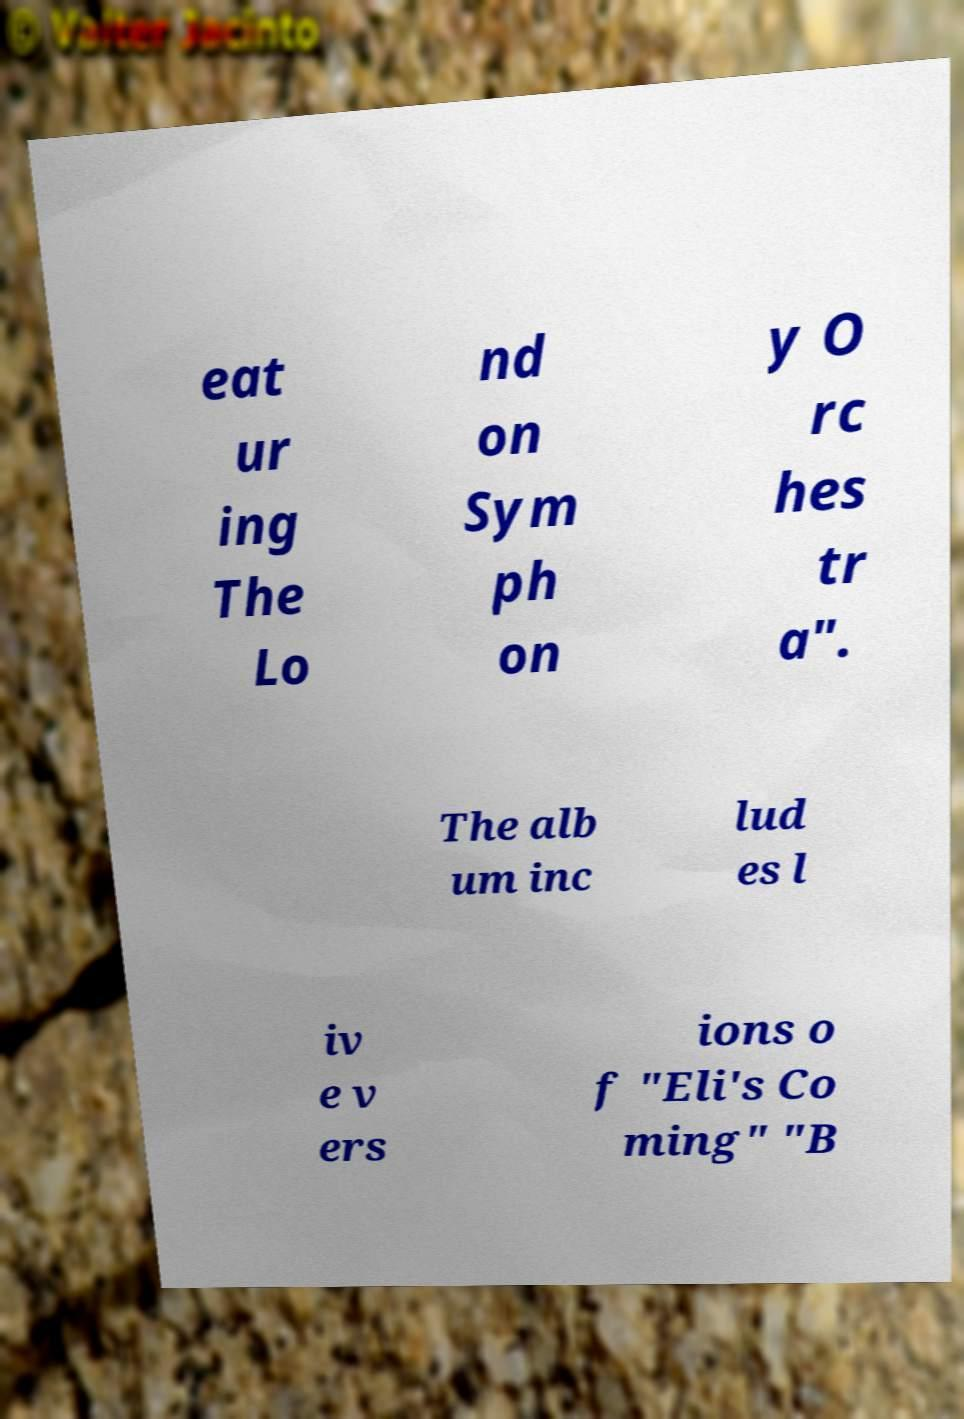There's text embedded in this image that I need extracted. Can you transcribe it verbatim? eat ur ing The Lo nd on Sym ph on y O rc hes tr a". The alb um inc lud es l iv e v ers ions o f "Eli's Co ming" "B 